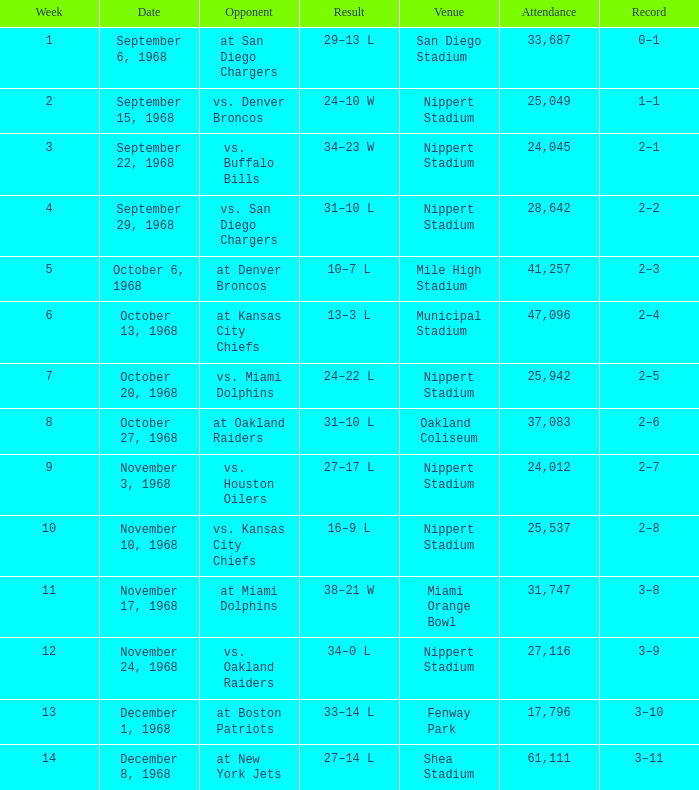What date was the week 6 game played on? October 13, 1968. 